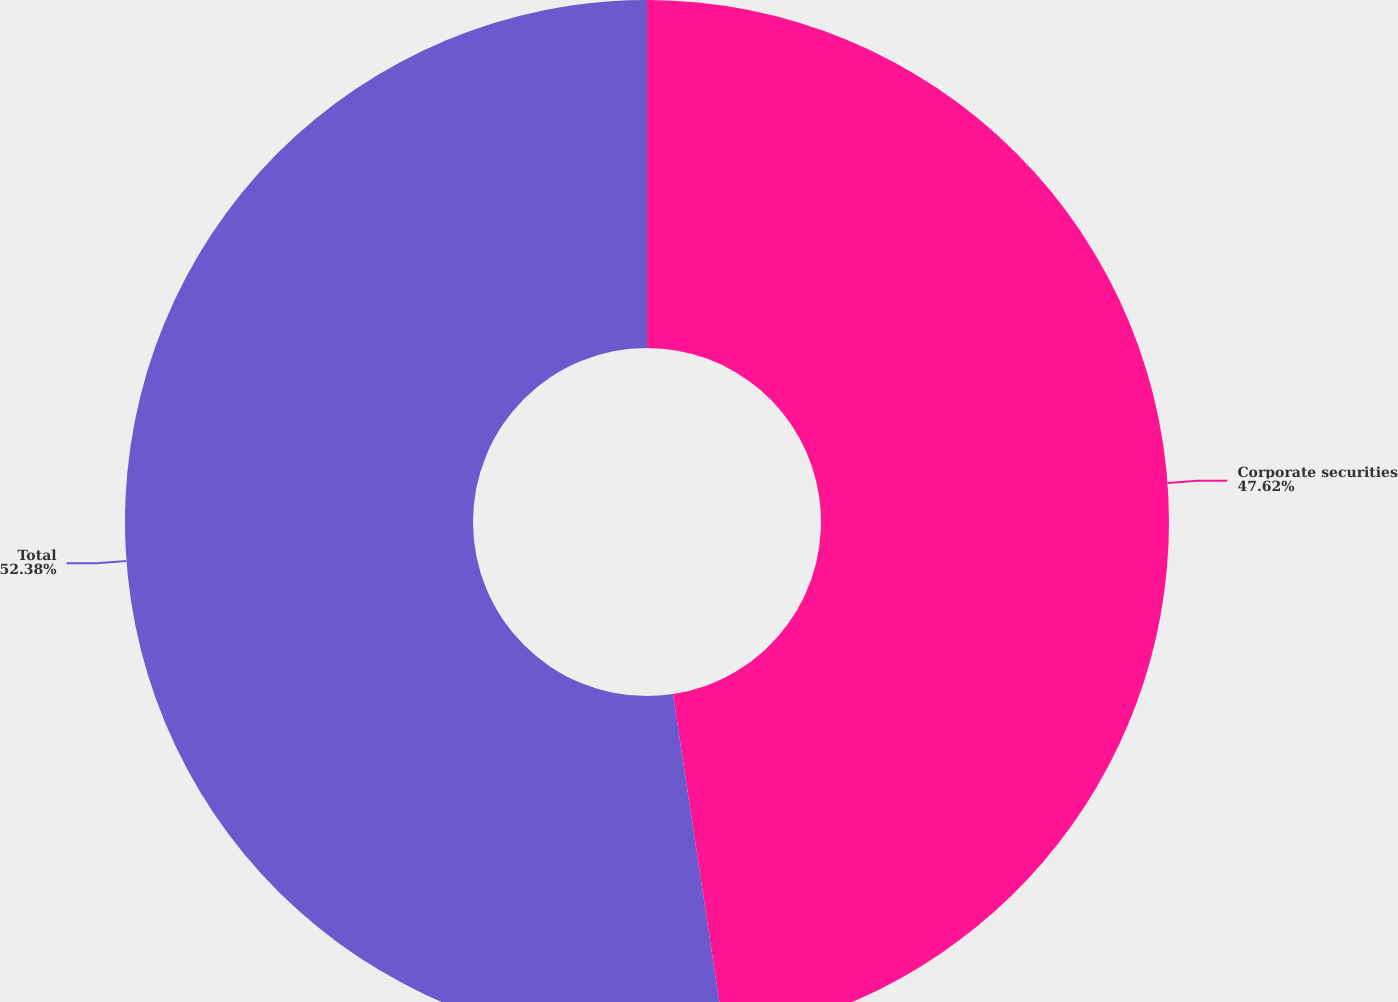Convert chart. <chart><loc_0><loc_0><loc_500><loc_500><pie_chart><fcel>Corporate securities<fcel>Total<nl><fcel>47.62%<fcel>52.38%<nl></chart> 